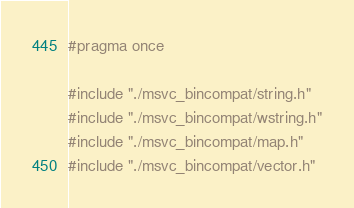<code> <loc_0><loc_0><loc_500><loc_500><_C_>#pragma once

#include "./msvc_bincompat/string.h"
#include "./msvc_bincompat/wstring.h"
#include "./msvc_bincompat/map.h"
#include "./msvc_bincompat/vector.h"

</code> 